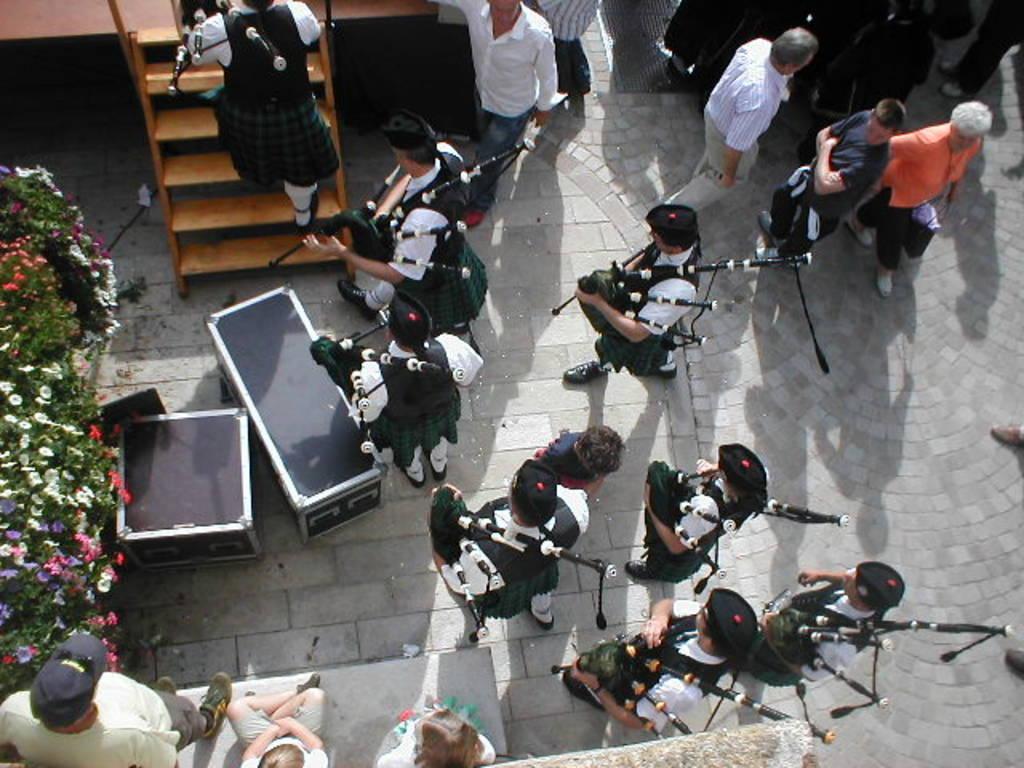In one or two sentences, can you explain what this image depicts? In this image I can see number of persons are standing and holding bagpipes in their hands. I can see few boxes, few other persons, few stairs, few plants and few flowers which are red, pink, white and purple in color. 